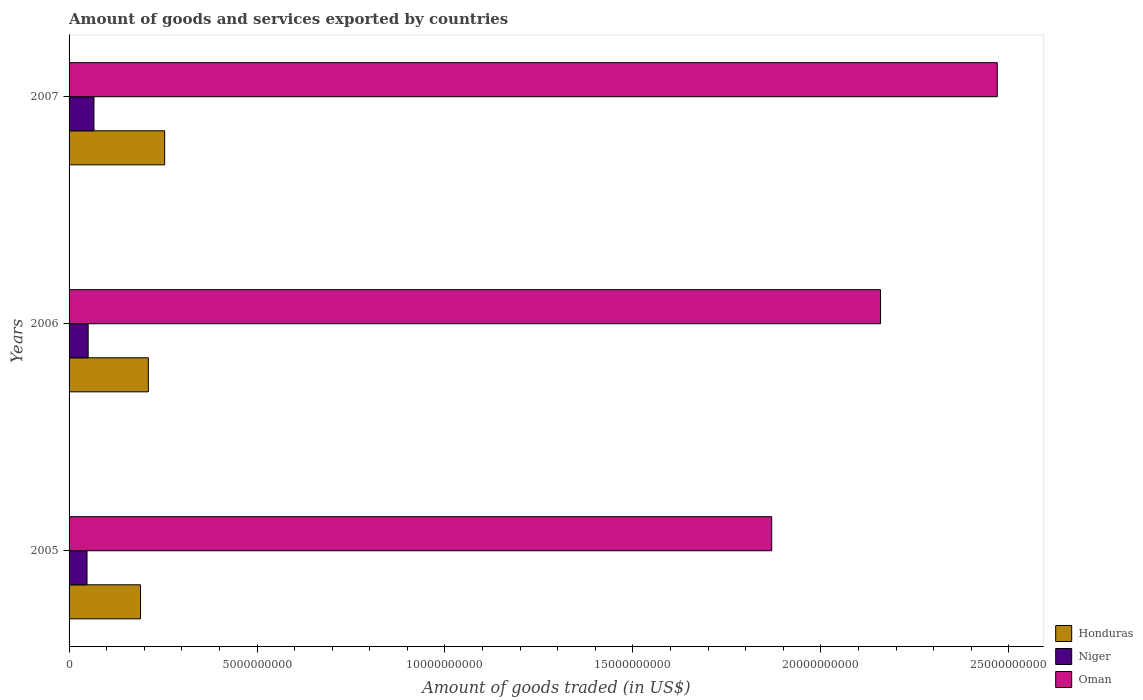How many groups of bars are there?
Offer a very short reply. 3. Are the number of bars per tick equal to the number of legend labels?
Your response must be concise. Yes. Are the number of bars on each tick of the Y-axis equal?
Give a very brief answer. Yes. How many bars are there on the 3rd tick from the top?
Keep it short and to the point. 3. In how many cases, is the number of bars for a given year not equal to the number of legend labels?
Offer a very short reply. 0. What is the total amount of goods and services exported in Oman in 2006?
Your answer should be very brief. 2.16e+1. Across all years, what is the maximum total amount of goods and services exported in Niger?
Ensure brevity in your answer.  6.63e+08. Across all years, what is the minimum total amount of goods and services exported in Niger?
Your answer should be very brief. 4.78e+08. In which year was the total amount of goods and services exported in Honduras minimum?
Make the answer very short. 2005. What is the total total amount of goods and services exported in Honduras in the graph?
Your response must be concise. 6.55e+09. What is the difference between the total amount of goods and services exported in Niger in 2005 and that in 2007?
Give a very brief answer. -1.85e+08. What is the difference between the total amount of goods and services exported in Oman in 2005 and the total amount of goods and services exported in Niger in 2007?
Ensure brevity in your answer.  1.80e+1. What is the average total amount of goods and services exported in Niger per year?
Your response must be concise. 5.49e+08. In the year 2005, what is the difference between the total amount of goods and services exported in Honduras and total amount of goods and services exported in Oman?
Keep it short and to the point. -1.68e+1. What is the ratio of the total amount of goods and services exported in Niger in 2005 to that in 2006?
Offer a very short reply. 0.94. Is the difference between the total amount of goods and services exported in Honduras in 2005 and 2006 greater than the difference between the total amount of goods and services exported in Oman in 2005 and 2006?
Provide a succinct answer. Yes. What is the difference between the highest and the second highest total amount of goods and services exported in Niger?
Offer a terse response. 1.55e+08. What is the difference between the highest and the lowest total amount of goods and services exported in Honduras?
Your answer should be compact. 6.42e+08. What does the 3rd bar from the top in 2006 represents?
Ensure brevity in your answer.  Honduras. What does the 3rd bar from the bottom in 2005 represents?
Ensure brevity in your answer.  Oman. Are all the bars in the graph horizontal?
Provide a succinct answer. Yes. What is the difference between two consecutive major ticks on the X-axis?
Offer a very short reply. 5.00e+09. Does the graph contain any zero values?
Offer a terse response. No. Where does the legend appear in the graph?
Keep it short and to the point. Bottom right. What is the title of the graph?
Your answer should be very brief. Amount of goods and services exported by countries. Does "Lesotho" appear as one of the legend labels in the graph?
Your response must be concise. No. What is the label or title of the X-axis?
Your response must be concise. Amount of goods traded (in US$). What is the label or title of the Y-axis?
Provide a succinct answer. Years. What is the Amount of goods traded (in US$) of Honduras in 2005?
Provide a short and direct response. 1.90e+09. What is the Amount of goods traded (in US$) of Niger in 2005?
Provide a succinct answer. 4.78e+08. What is the Amount of goods traded (in US$) in Oman in 2005?
Provide a short and direct response. 1.87e+1. What is the Amount of goods traded (in US$) of Honduras in 2006?
Provide a short and direct response. 2.11e+09. What is the Amount of goods traded (in US$) of Niger in 2006?
Offer a very short reply. 5.08e+08. What is the Amount of goods traded (in US$) of Oman in 2006?
Make the answer very short. 2.16e+1. What is the Amount of goods traded (in US$) of Honduras in 2007?
Offer a terse response. 2.54e+09. What is the Amount of goods traded (in US$) in Niger in 2007?
Your answer should be compact. 6.63e+08. What is the Amount of goods traded (in US$) of Oman in 2007?
Provide a short and direct response. 2.47e+1. Across all years, what is the maximum Amount of goods traded (in US$) of Honduras?
Provide a succinct answer. 2.54e+09. Across all years, what is the maximum Amount of goods traded (in US$) of Niger?
Your answer should be compact. 6.63e+08. Across all years, what is the maximum Amount of goods traded (in US$) of Oman?
Your answer should be very brief. 2.47e+1. Across all years, what is the minimum Amount of goods traded (in US$) of Honduras?
Your response must be concise. 1.90e+09. Across all years, what is the minimum Amount of goods traded (in US$) in Niger?
Your response must be concise. 4.78e+08. Across all years, what is the minimum Amount of goods traded (in US$) in Oman?
Provide a short and direct response. 1.87e+1. What is the total Amount of goods traded (in US$) of Honduras in the graph?
Offer a very short reply. 6.55e+09. What is the total Amount of goods traded (in US$) of Niger in the graph?
Keep it short and to the point. 1.65e+09. What is the total Amount of goods traded (in US$) of Oman in the graph?
Offer a terse response. 6.50e+1. What is the difference between the Amount of goods traded (in US$) in Honduras in 2005 and that in 2006?
Make the answer very short. -2.08e+08. What is the difference between the Amount of goods traded (in US$) of Niger in 2005 and that in 2006?
Your response must be concise. -3.04e+07. What is the difference between the Amount of goods traded (in US$) in Oman in 2005 and that in 2006?
Your response must be concise. -2.89e+09. What is the difference between the Amount of goods traded (in US$) in Honduras in 2005 and that in 2007?
Keep it short and to the point. -6.42e+08. What is the difference between the Amount of goods traded (in US$) of Niger in 2005 and that in 2007?
Provide a short and direct response. -1.85e+08. What is the difference between the Amount of goods traded (in US$) of Oman in 2005 and that in 2007?
Your answer should be compact. -6.00e+09. What is the difference between the Amount of goods traded (in US$) in Honduras in 2006 and that in 2007?
Offer a terse response. -4.34e+08. What is the difference between the Amount of goods traded (in US$) in Niger in 2006 and that in 2007?
Provide a succinct answer. -1.55e+08. What is the difference between the Amount of goods traded (in US$) of Oman in 2006 and that in 2007?
Give a very brief answer. -3.11e+09. What is the difference between the Amount of goods traded (in US$) of Honduras in 2005 and the Amount of goods traded (in US$) of Niger in 2006?
Give a very brief answer. 1.39e+09. What is the difference between the Amount of goods traded (in US$) of Honduras in 2005 and the Amount of goods traded (in US$) of Oman in 2006?
Give a very brief answer. -1.97e+1. What is the difference between the Amount of goods traded (in US$) in Niger in 2005 and the Amount of goods traded (in US$) in Oman in 2006?
Give a very brief answer. -2.11e+1. What is the difference between the Amount of goods traded (in US$) of Honduras in 2005 and the Amount of goods traded (in US$) of Niger in 2007?
Make the answer very short. 1.24e+09. What is the difference between the Amount of goods traded (in US$) in Honduras in 2005 and the Amount of goods traded (in US$) in Oman in 2007?
Keep it short and to the point. -2.28e+1. What is the difference between the Amount of goods traded (in US$) of Niger in 2005 and the Amount of goods traded (in US$) of Oman in 2007?
Your response must be concise. -2.42e+1. What is the difference between the Amount of goods traded (in US$) in Honduras in 2006 and the Amount of goods traded (in US$) in Niger in 2007?
Provide a succinct answer. 1.45e+09. What is the difference between the Amount of goods traded (in US$) in Honduras in 2006 and the Amount of goods traded (in US$) in Oman in 2007?
Your response must be concise. -2.26e+1. What is the difference between the Amount of goods traded (in US$) in Niger in 2006 and the Amount of goods traded (in US$) in Oman in 2007?
Provide a succinct answer. -2.42e+1. What is the average Amount of goods traded (in US$) in Honduras per year?
Your response must be concise. 2.18e+09. What is the average Amount of goods traded (in US$) of Niger per year?
Your answer should be compact. 5.49e+08. What is the average Amount of goods traded (in US$) of Oman per year?
Your answer should be compact. 2.17e+1. In the year 2005, what is the difference between the Amount of goods traded (in US$) of Honduras and Amount of goods traded (in US$) of Niger?
Your answer should be compact. 1.42e+09. In the year 2005, what is the difference between the Amount of goods traded (in US$) of Honduras and Amount of goods traded (in US$) of Oman?
Provide a short and direct response. -1.68e+1. In the year 2005, what is the difference between the Amount of goods traded (in US$) of Niger and Amount of goods traded (in US$) of Oman?
Make the answer very short. -1.82e+1. In the year 2006, what is the difference between the Amount of goods traded (in US$) of Honduras and Amount of goods traded (in US$) of Niger?
Make the answer very short. 1.60e+09. In the year 2006, what is the difference between the Amount of goods traded (in US$) in Honduras and Amount of goods traded (in US$) in Oman?
Offer a very short reply. -1.95e+1. In the year 2006, what is the difference between the Amount of goods traded (in US$) of Niger and Amount of goods traded (in US$) of Oman?
Your answer should be very brief. -2.11e+1. In the year 2007, what is the difference between the Amount of goods traded (in US$) in Honduras and Amount of goods traded (in US$) in Niger?
Make the answer very short. 1.88e+09. In the year 2007, what is the difference between the Amount of goods traded (in US$) in Honduras and Amount of goods traded (in US$) in Oman?
Keep it short and to the point. -2.21e+1. In the year 2007, what is the difference between the Amount of goods traded (in US$) in Niger and Amount of goods traded (in US$) in Oman?
Your answer should be compact. -2.40e+1. What is the ratio of the Amount of goods traded (in US$) in Honduras in 2005 to that in 2006?
Give a very brief answer. 0.9. What is the ratio of the Amount of goods traded (in US$) in Niger in 2005 to that in 2006?
Keep it short and to the point. 0.94. What is the ratio of the Amount of goods traded (in US$) of Oman in 2005 to that in 2006?
Your answer should be very brief. 0.87. What is the ratio of the Amount of goods traded (in US$) in Honduras in 2005 to that in 2007?
Provide a short and direct response. 0.75. What is the ratio of the Amount of goods traded (in US$) of Niger in 2005 to that in 2007?
Offer a very short reply. 0.72. What is the ratio of the Amount of goods traded (in US$) of Oman in 2005 to that in 2007?
Ensure brevity in your answer.  0.76. What is the ratio of the Amount of goods traded (in US$) in Honduras in 2006 to that in 2007?
Your answer should be very brief. 0.83. What is the ratio of the Amount of goods traded (in US$) of Niger in 2006 to that in 2007?
Your answer should be very brief. 0.77. What is the ratio of the Amount of goods traded (in US$) in Oman in 2006 to that in 2007?
Your response must be concise. 0.87. What is the difference between the highest and the second highest Amount of goods traded (in US$) in Honduras?
Your response must be concise. 4.34e+08. What is the difference between the highest and the second highest Amount of goods traded (in US$) in Niger?
Give a very brief answer. 1.55e+08. What is the difference between the highest and the second highest Amount of goods traded (in US$) of Oman?
Your answer should be very brief. 3.11e+09. What is the difference between the highest and the lowest Amount of goods traded (in US$) of Honduras?
Make the answer very short. 6.42e+08. What is the difference between the highest and the lowest Amount of goods traded (in US$) in Niger?
Offer a terse response. 1.85e+08. What is the difference between the highest and the lowest Amount of goods traded (in US$) of Oman?
Ensure brevity in your answer.  6.00e+09. 